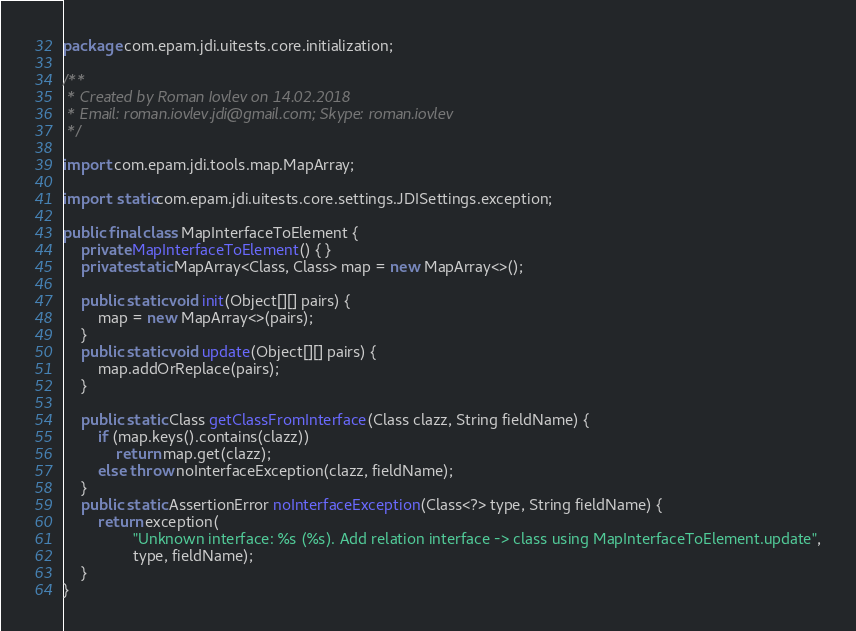Convert code to text. <code><loc_0><loc_0><loc_500><loc_500><_Java_>package com.epam.jdi.uitests.core.initialization;

/**
 * Created by Roman Iovlev on 14.02.2018
 * Email: roman.iovlev.jdi@gmail.com; Skype: roman.iovlev
 */

import com.epam.jdi.tools.map.MapArray;

import static com.epam.jdi.uitests.core.settings.JDISettings.exception;

public final class MapInterfaceToElement {
    private MapInterfaceToElement() { }
    private static MapArray<Class, Class> map = new MapArray<>();

    public static void init(Object[][] pairs) {
        map = new MapArray<>(pairs);
    }
    public static void update(Object[][] pairs) {
        map.addOrReplace(pairs);
    }

    public static Class getClassFromInterface(Class clazz, String fieldName) {
        if (map.keys().contains(clazz))
            return map.get(clazz);
        else throw noInterfaceException(clazz, fieldName);
    }
    public static AssertionError noInterfaceException(Class<?> type, String fieldName) {
        return exception(
                "Unknown interface: %s (%s). Add relation interface -> class using MapInterfaceToElement.update",
                type, fieldName);
    }
}</code> 